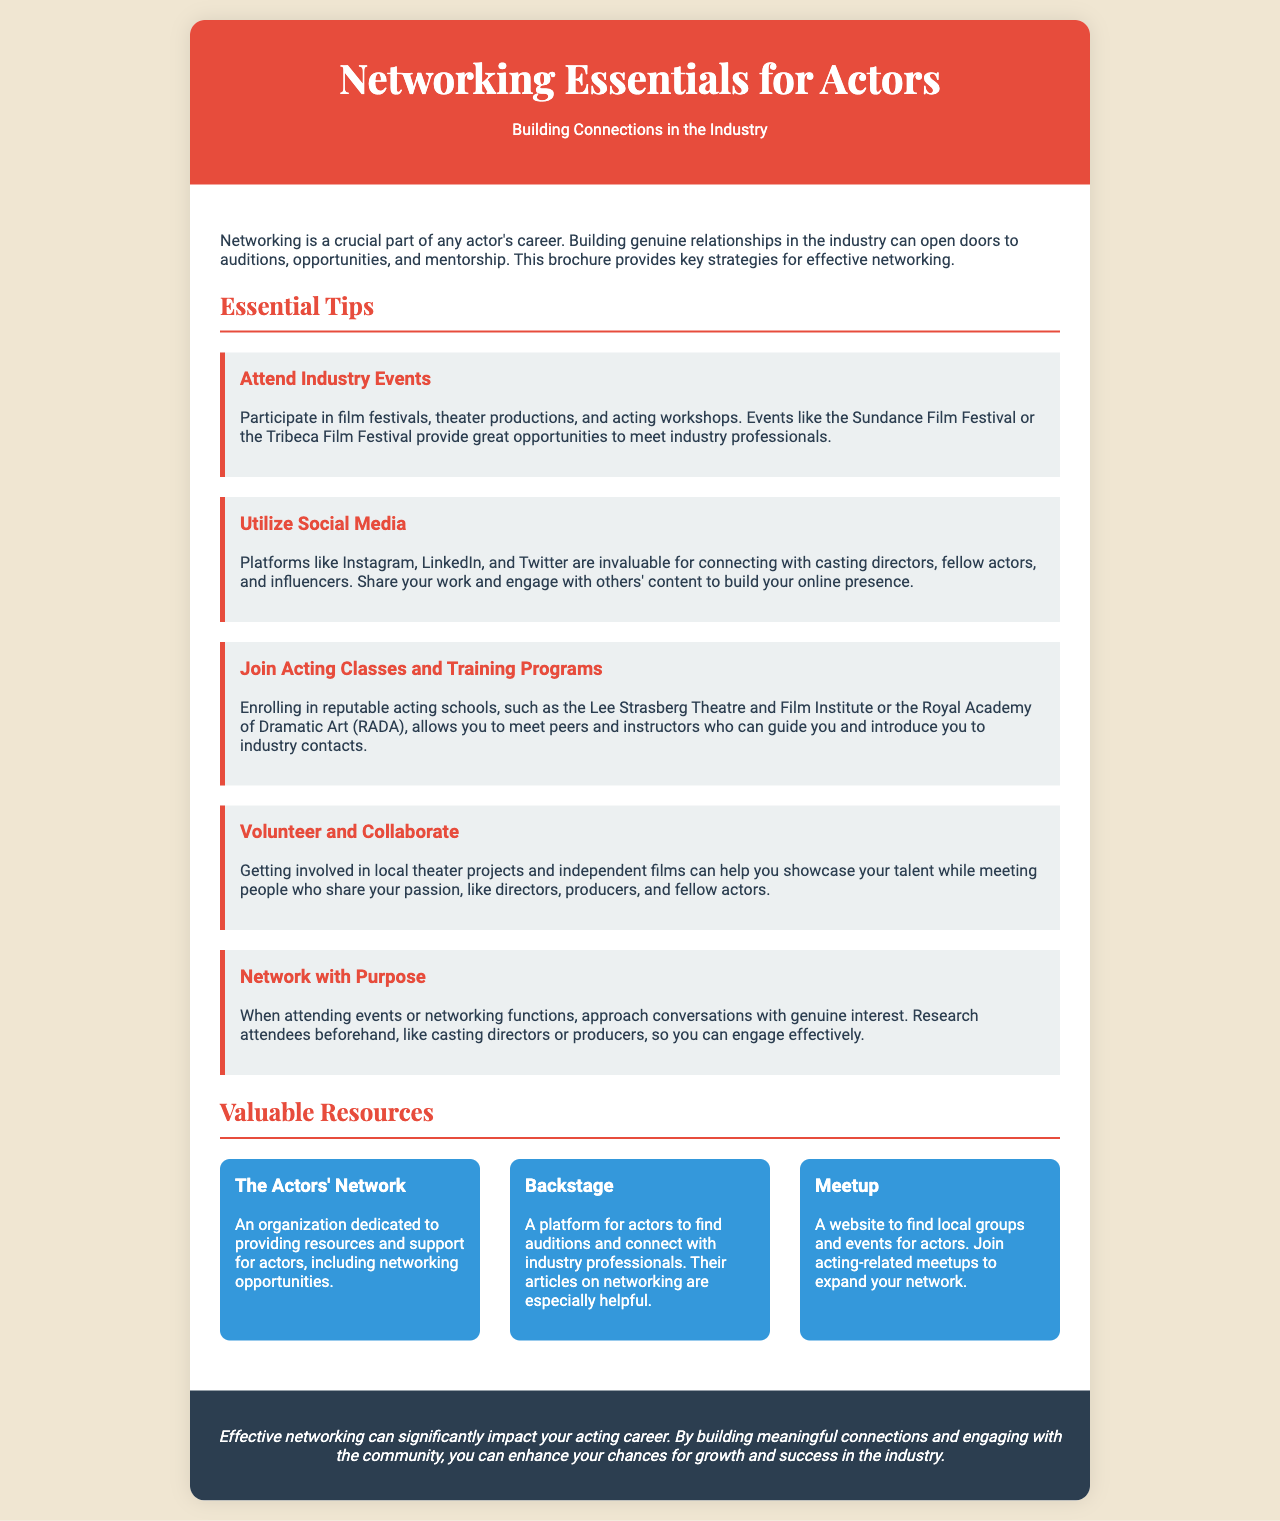What is the title of the brochure? The title is prominently displayed at the top of the document.
Answer: Networking Essentials for Actors What is one networking event mentioned? The brochure lists a specific event as an opportunity for networking.
Answer: Sundance Film Festival Which social media platform is mentioned for networking? The document references specific platforms useful for connecting in the industry.
Answer: Instagram What is the purpose of The Actors' Network? The document describes the function of this organization within the context provided.
Answer: Providing resources and support for actors How many tips are provided under "Essential Tips"? The total count of tips listed in this section gives insight into the breadth of advice offered.
Answer: Five What kind of programs can help actors meet industry contacts according to the brochure? The document suggests a type of program beneficial for networking.
Answer: Acting classes What color is the header of the brochure? The header's color is explicitly stated in the document's style.
Answer: Red What is the concluding message's emphasis regarding networking? The conclusion summarizes the overall impact of networking on an actor's career.
Answer: Significantly impact your acting career 